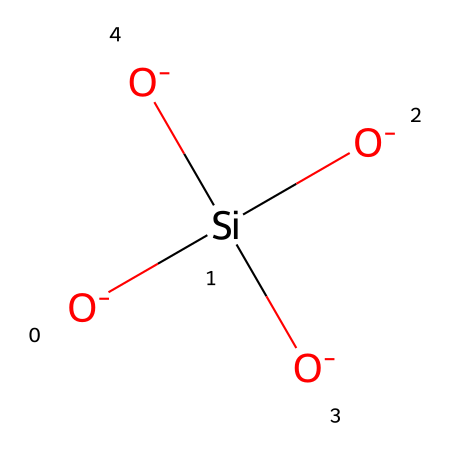What is the central atom in this chemical structure? The central atom can be identified by looking for the atom that is bonded to multiple oxygen atoms—in this case, silicon is the central atom as it is connected to four oxygen atoms.
Answer: silicon How many oxygen atoms are present in this structure? By examining the chemical structure, we can count the number of oxygen atoms, which are depicted in the structure. There are four oxygen atoms connected to the silicon ion.
Answer: four What type of bond connects the silicon atom to the oxygen atoms? The bonds connecting silicon to the oxygen atoms are covalent bonds, as they involve the sharing of electrons between the silicon and oxygen atoms.
Answer: covalent What is the formal charge on each oxygen atom? The formal charge on each oxygen atom can be calculated using the formula (valence electrons - non-bonding electrons - 0.5 * bonding electrons). Each oxygen in this structure has a formal charge of -1.
Answer: -1 What type of structure does this chemical likely contribute to in sacred rock formations? Given the context and the presence of silicon and oxygen, this chemical likely contributes to a crystalline structure, as quartz forms a common crystalline mineral structure due to its tetrahedral arrangement.
Answer: crystalline What property of quartz is indicated by its silica composition? The silica composition indicates that quartz generally exhibits high durability and resistance to weathering due to its strong covalent bonds between silicon and oxygen.
Answer: high durability 